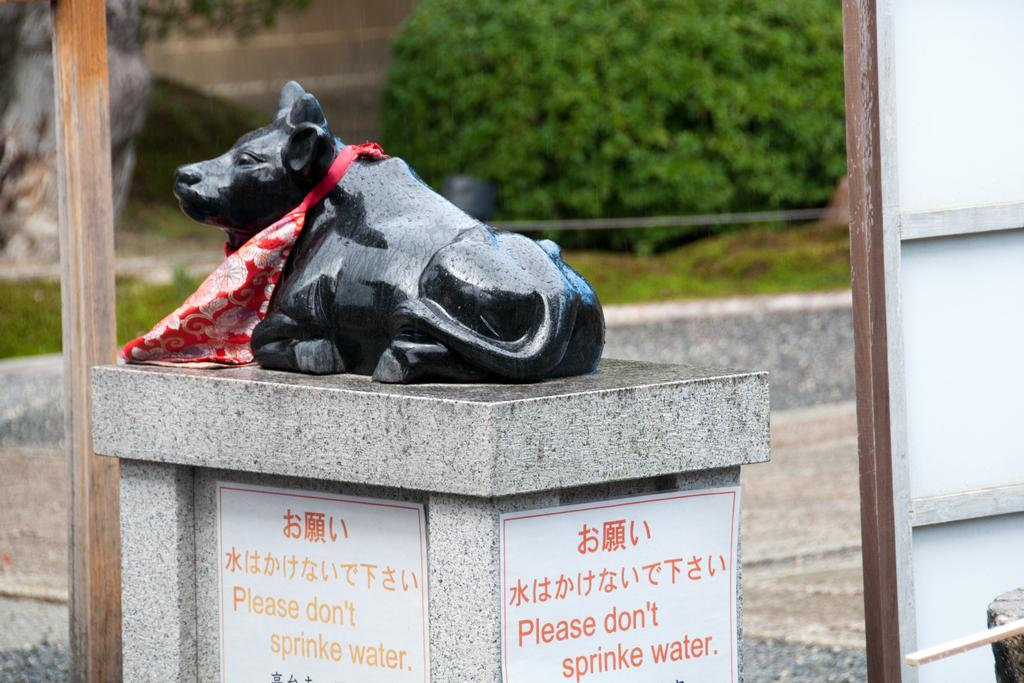What is the main subject of the image? There is a statue of an animal in the image. What is the statue standing on? The statue is on a marble pillar. Can you describe the background in the image? The background behind the statue is blurry. Where can the shop selling calculators be found in the image? There is no shop or calculators present in the image; it only features a statue of an animal on a marble pillar with a blurry background. 